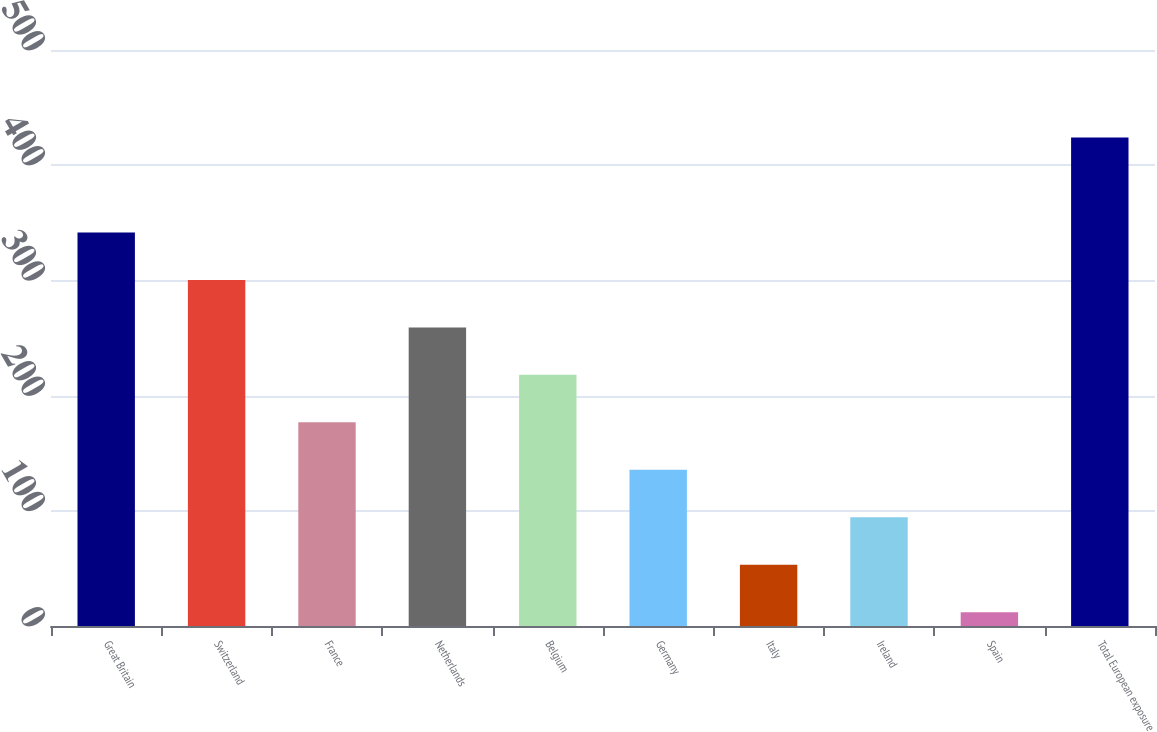Convert chart to OTSL. <chart><loc_0><loc_0><loc_500><loc_500><bar_chart><fcel>Great Britain<fcel>Switzerland<fcel>France<fcel>Netherlands<fcel>Belgium<fcel>Germany<fcel>Italy<fcel>Ireland<fcel>Spain<fcel>Total European exposure<nl><fcel>341.6<fcel>300.4<fcel>176.8<fcel>259.2<fcel>218<fcel>135.6<fcel>53.2<fcel>94.4<fcel>12<fcel>424<nl></chart> 